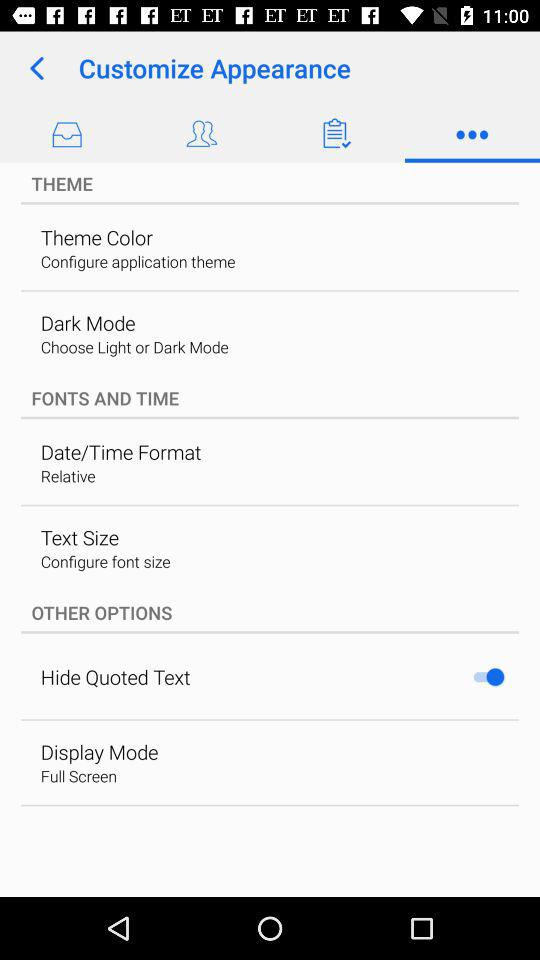What is the description of "Theme Color"? The description of "Theme Color" is "Configure application theme". 